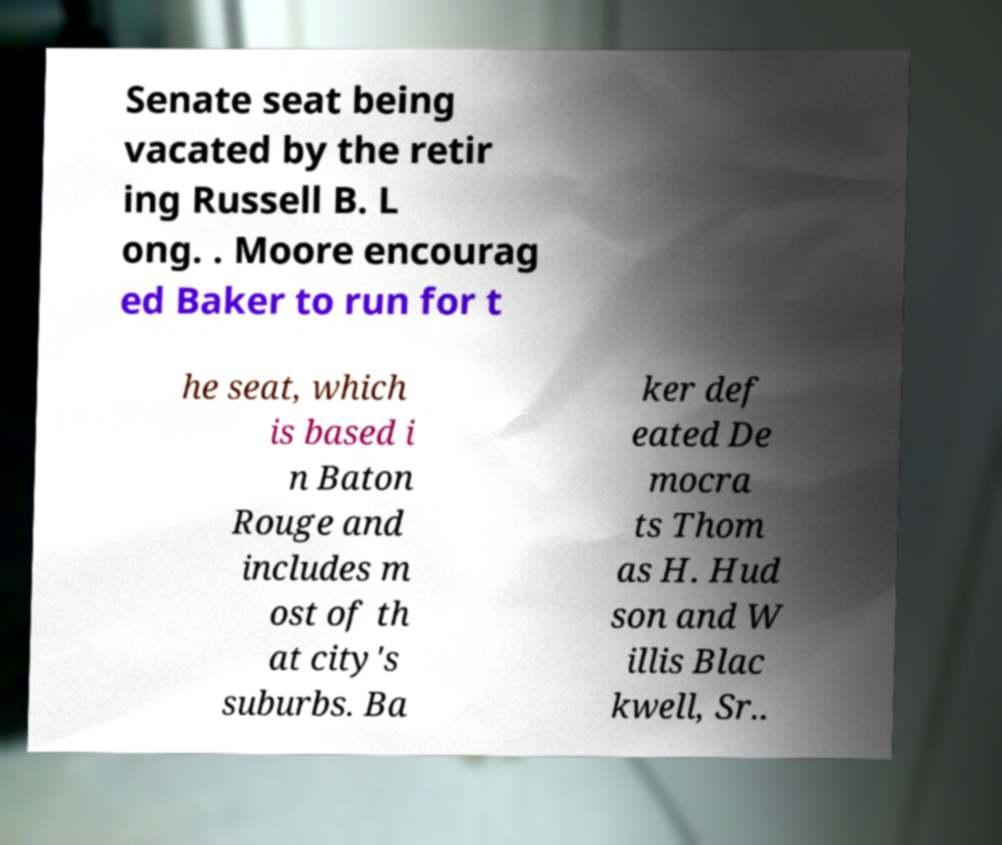Please identify and transcribe the text found in this image. Senate seat being vacated by the retir ing Russell B. L ong. . Moore encourag ed Baker to run for t he seat, which is based i n Baton Rouge and includes m ost of th at city's suburbs. Ba ker def eated De mocra ts Thom as H. Hud son and W illis Blac kwell, Sr.. 